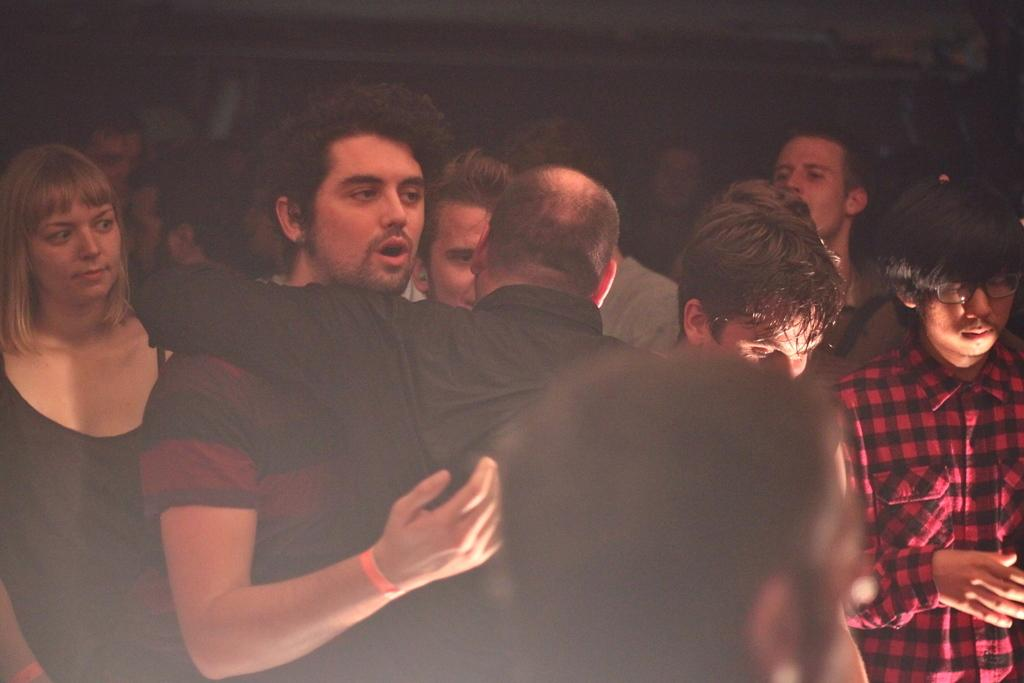How many people are in the image? There is a group of people standing in the image. Can you describe any specific interactions between the people? Two people are hugging each other in the image. What can be observed about the lighting or color of the background in the image? The background of the image appears dark. Can you tell me how many frogs are jumping in the image? There are no frogs present in the image; it features a group of people standing and hugging. What type of sponge is being used by the people in the image? There is no sponge visible in the image; it only shows people standing and hugging. 